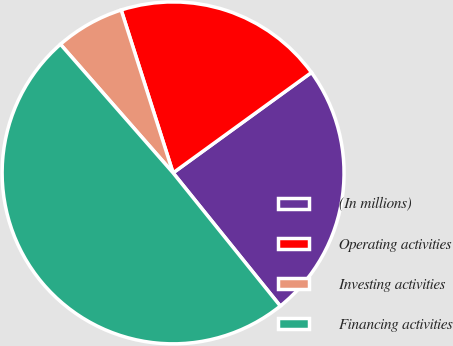Convert chart. <chart><loc_0><loc_0><loc_500><loc_500><pie_chart><fcel>(In millions)<fcel>Operating activities<fcel>Investing activities<fcel>Financing activities<nl><fcel>24.2%<fcel>19.92%<fcel>6.54%<fcel>49.34%<nl></chart> 